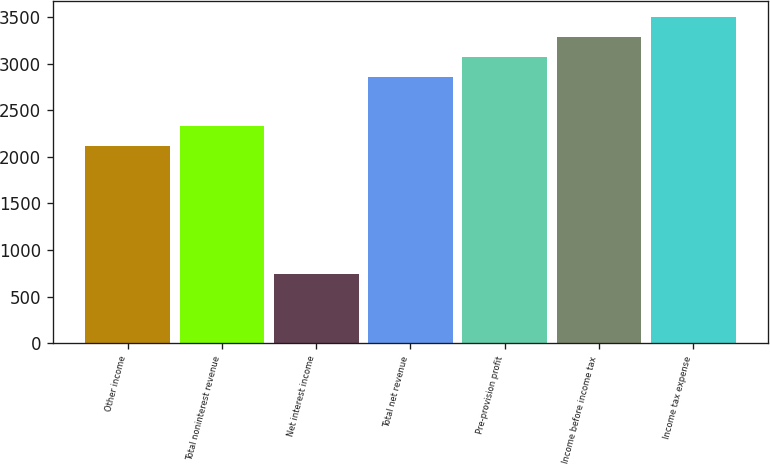<chart> <loc_0><loc_0><loc_500><loc_500><bar_chart><fcel>Other income<fcel>Total noninterest revenue<fcel>Net interest income<fcel>Total net revenue<fcel>Pre-provision profit<fcel>Income before income tax<fcel>Income tax expense<nl><fcel>2116<fcel>2327.6<fcel>743<fcel>2859<fcel>3070.6<fcel>3282.2<fcel>3493.8<nl></chart> 